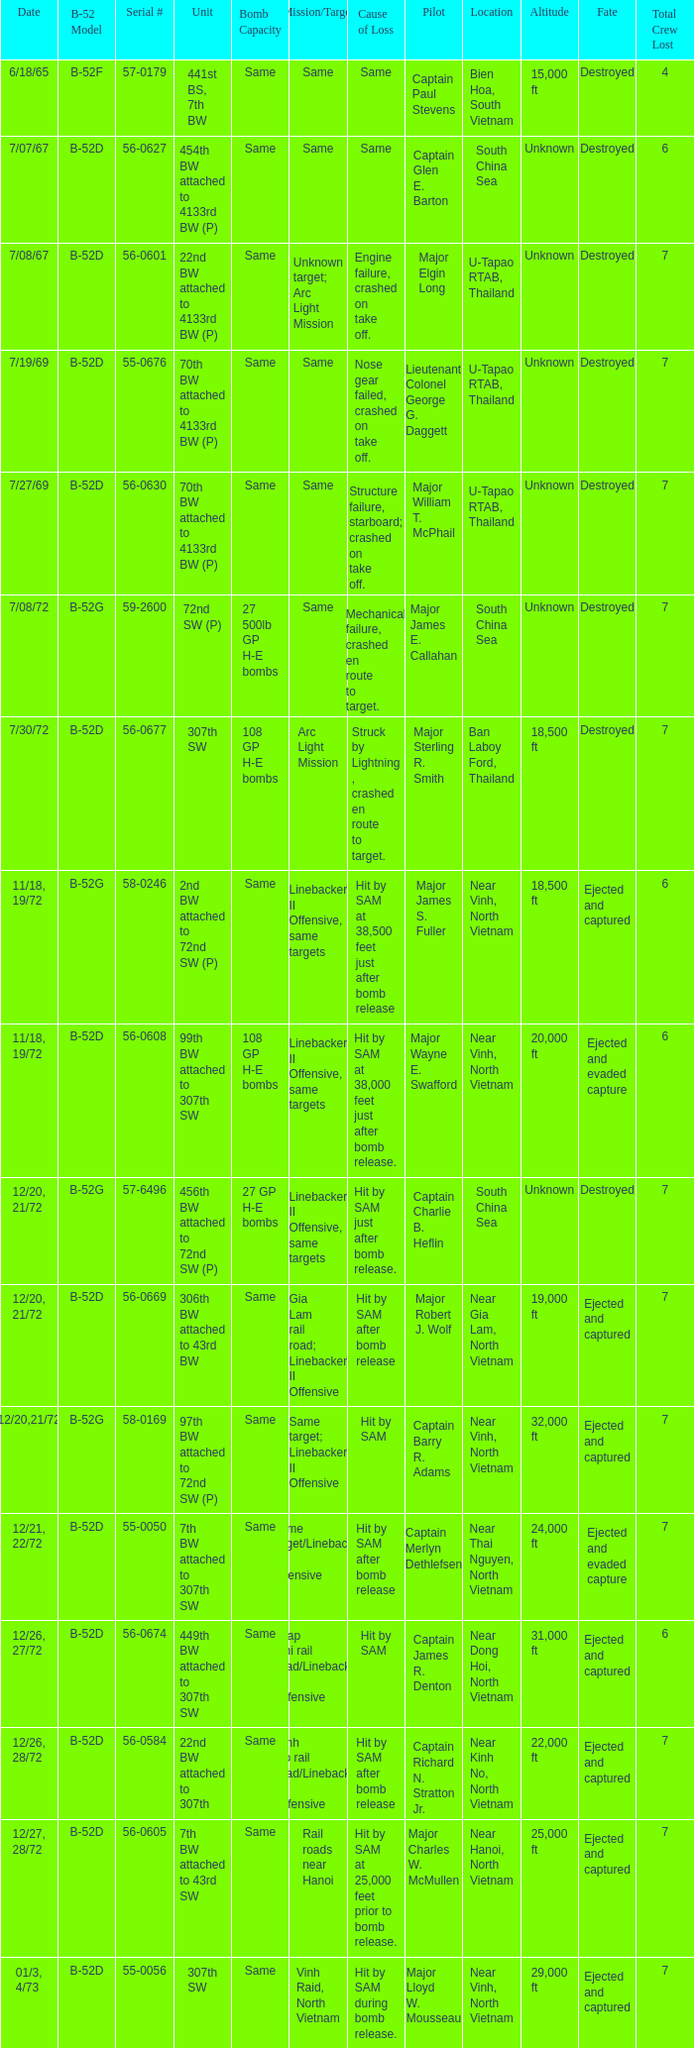When  27 gp h-e bombs the capacity of the bomb what is the cause of loss? Hit by SAM just after bomb release. 